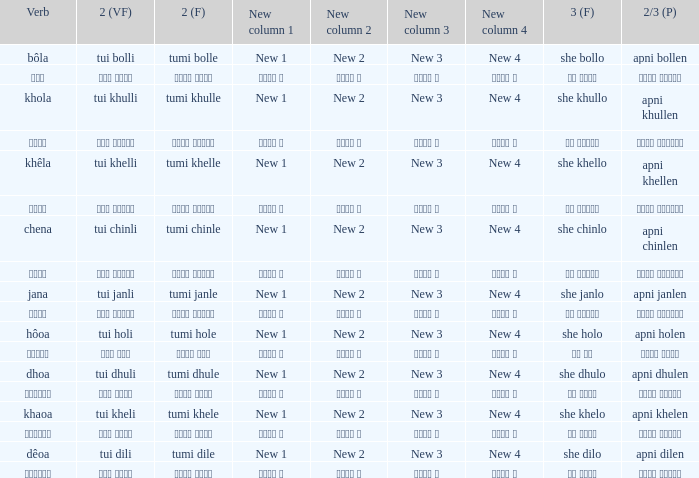What is the 2nd verb for Khola? Tumi khulle. 